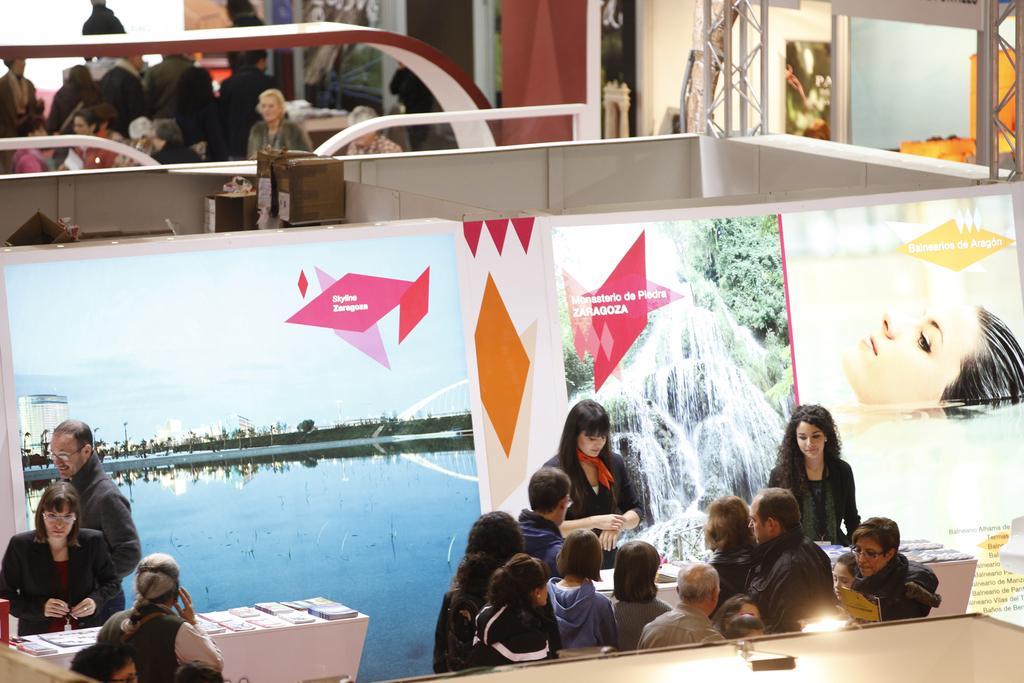Can you describe this image briefly? people are standing. there are tables between them on which there are books. behind them in other room people are standing. in the middle there is a banner on which zaragoza is written. 